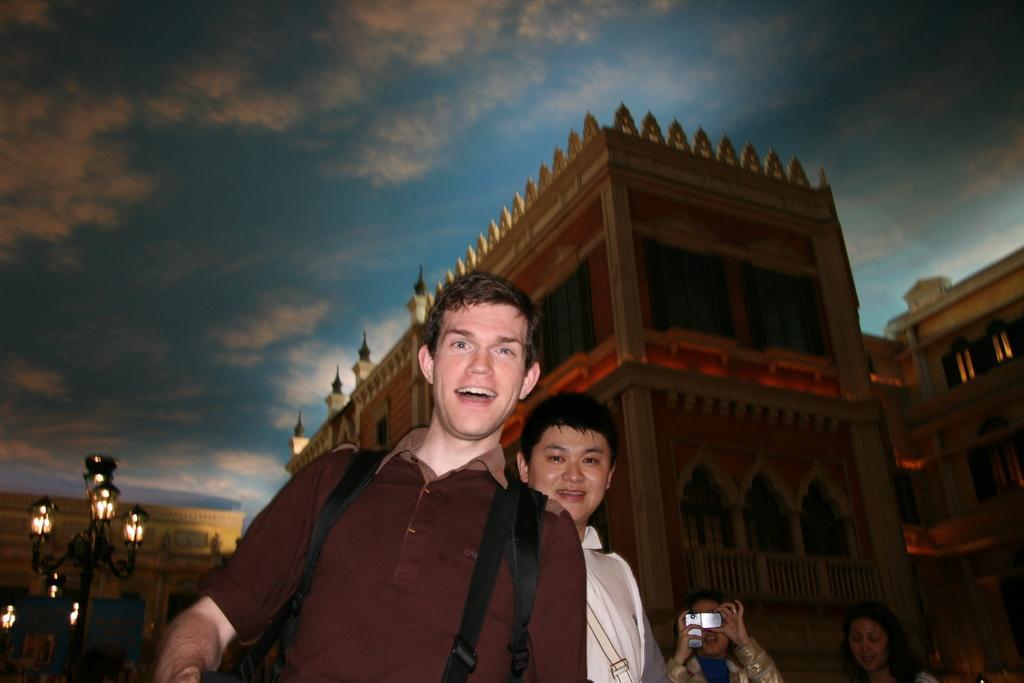Could you give a brief overview of what you see in this image? In this picture I can see there are few people standing here and smiling and in the backdrop there is a fort and there is a pole with some lights and the sky is clear. 